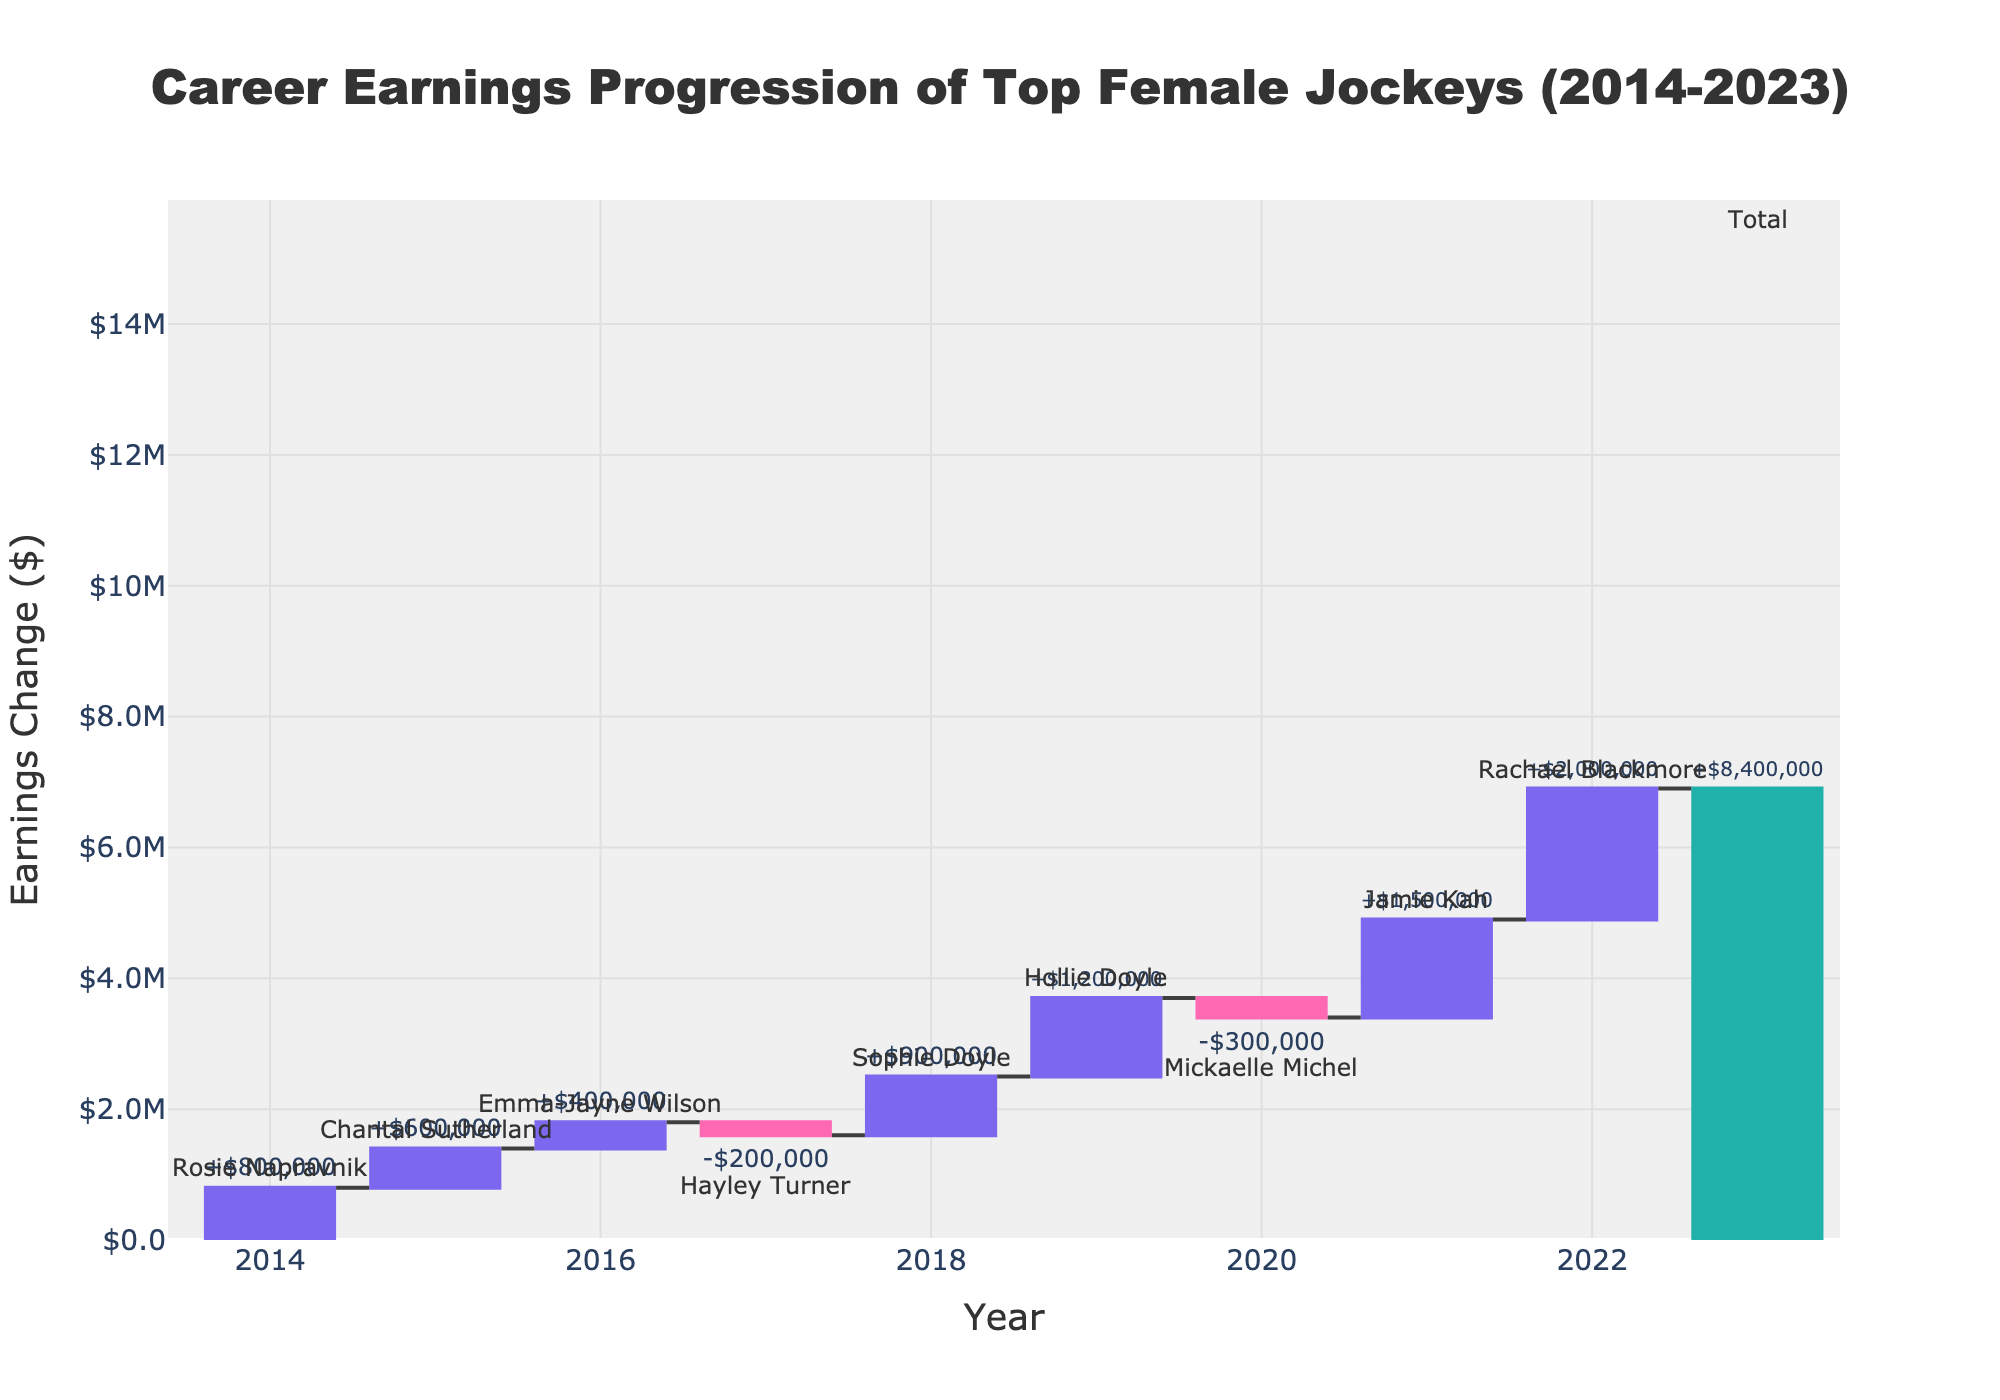What's the overall trend in career earnings progression for the top female jockeys from 2014 to 2023? Examine the Waterfall Chart and observe the earnings changes from year to year, culminating in the final total. The overall cumulative earnings are positive.
Answer: Upward Which year had the highest positive change in earnings among the jockeys? Look at each year's earnings change. The highest positive change has the largest increase bar.
Answer: 2022 Which jockey had a negative change in earnings in 2017? Identify the year 2017 in the chart and check the jockey's name associated with the negative earnings change for that year.
Answer: Hayley Turner What is the total cumulative earnings change by 2020? Sum up the earnings changes from 2014 to 2020 or look at the cumulative value for 2020 in the chart. The cumulative value directly beneath 2020 represents this.
Answer: +$3,400,000 Between which two consecutive years did we see the largest decrease in earnings? Compare the drops in earnings between consecutive years. The largest decrease will have the biggest drop between two bars.
Answer: 2019 to 2020 How many jockeys had a positive change in earnings? Count the number of bars that represent positive changes (upward bars) in the chart.
Answer: 6 Who was responsible for the largest individual positive change in career earnings? Look at the positive changes and determine which jockey had the largest increment in one specific year.
Answer: Rachael Blackmore What was the earnings change for the total period from 2014 to 2023? Look at the final bar labeled 'Total' for the cumulative earnings change over the entire period in the chart.
Answer: +$8,400,000 Which year marks the end of the earning change measurements in the chart? Look at the last year labeled in the chart before 'Total'.
Answer: 2022 